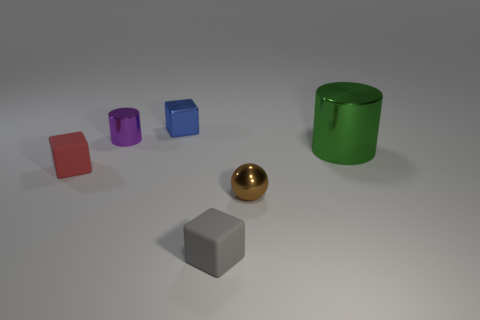Subtract 1 cubes. How many cubes are left? 2 Add 2 small cyan metal balls. How many objects exist? 8 Subtract all spheres. How many objects are left? 5 Subtract all small brown shiny things. Subtract all tiny green objects. How many objects are left? 5 Add 3 small things. How many small things are left? 8 Add 3 big yellow shiny things. How many big yellow shiny things exist? 3 Subtract 0 brown cubes. How many objects are left? 6 